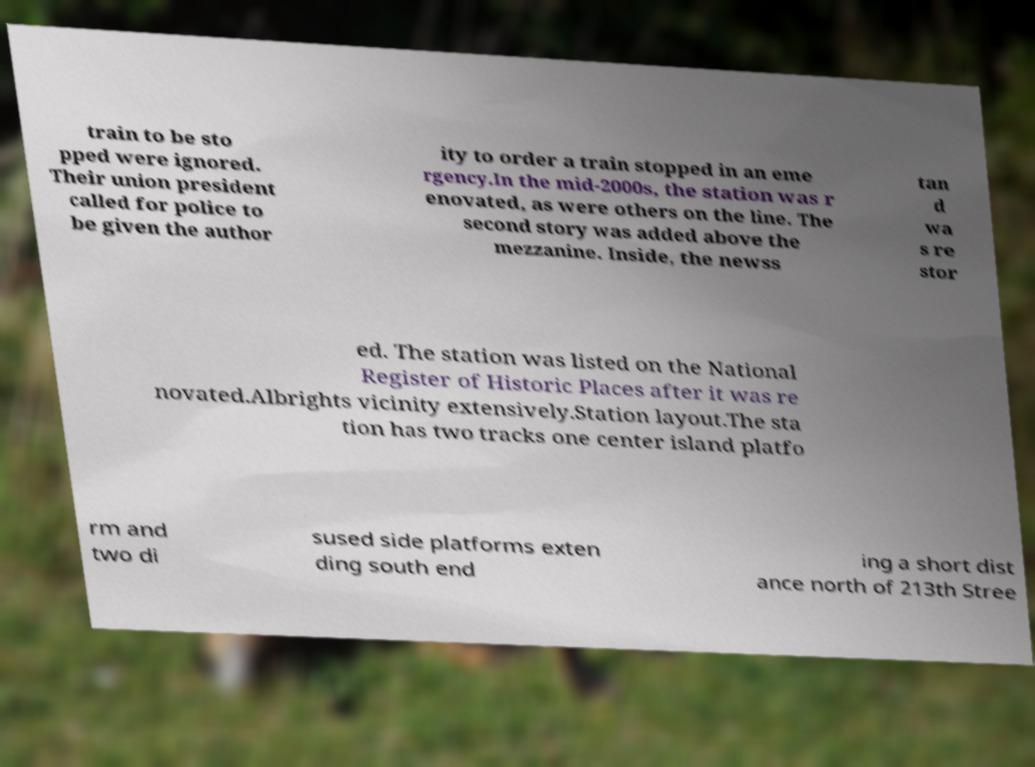Can you accurately transcribe the text from the provided image for me? train to be sto pped were ignored. Their union president called for police to be given the author ity to order a train stopped in an eme rgency.In the mid-2000s, the station was r enovated, as were others on the line. The second story was added above the mezzanine. Inside, the newss tan d wa s re stor ed. The station was listed on the National Register of Historic Places after it was re novated.Albrights vicinity extensively.Station layout.The sta tion has two tracks one center island platfo rm and two di sused side platforms exten ding south end ing a short dist ance north of 213th Stree 